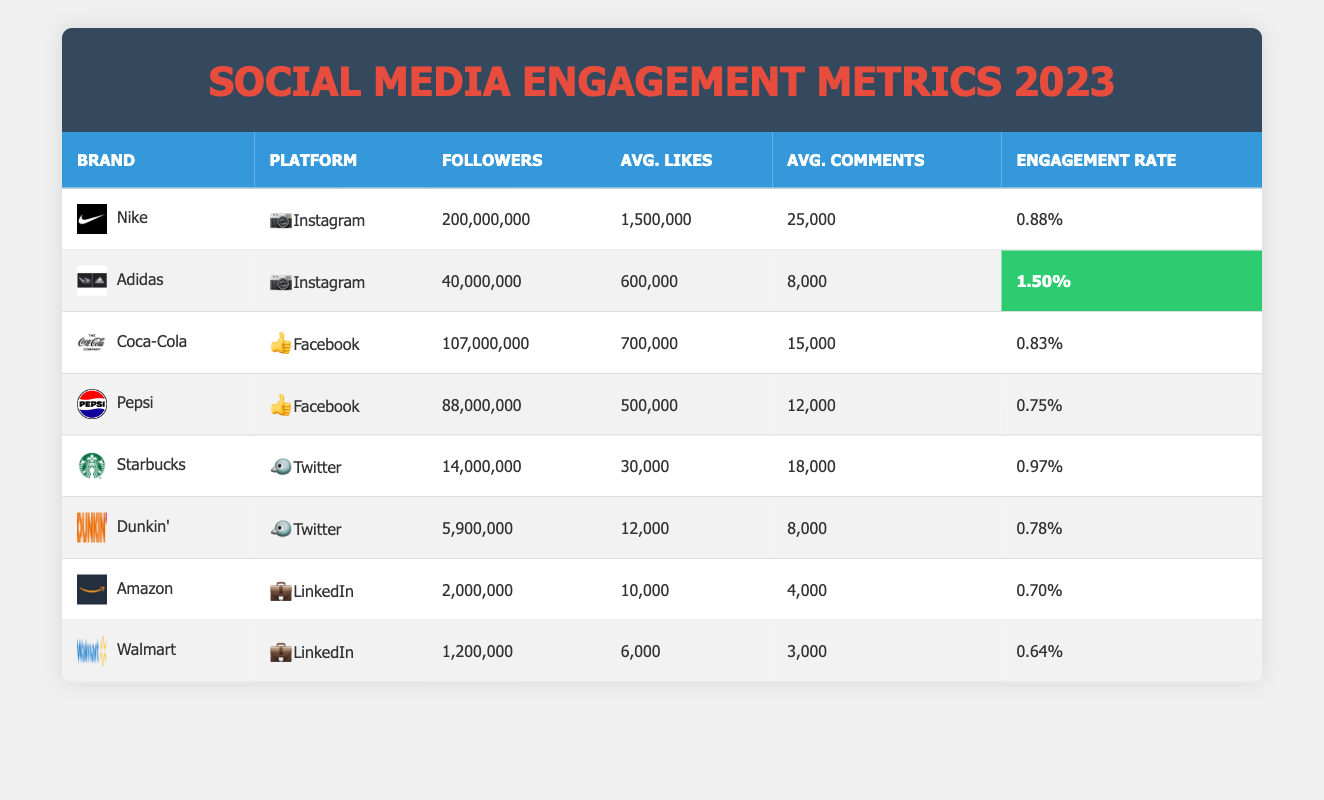What brand has the highest engagement rate on Instagram? Looking at the table, Adidas has the highest engagement rate on Instagram, listed as 1.5% next to the average likes and comments data.
Answer: Adidas Which brand has the most followers on Facebook? Coca-Cola has the most followers on Facebook with 107 million, compared to Pepsi's 88 million.
Answer: Coca-Cola How many average likes does Starbucks receive on Twitter? According to the table, Starbucks has an average of 30,000 likes on Twitter.
Answer: 30,000 What is the difference in followers between Nike and Adidas on Instagram? Nike has 200 million followers while Adidas has 40 million. The difference is 200 million - 40 million = 160 million.
Answer: 160 million Is Dunkin' more engaging than Walmart on LinkedIn? Dunkin' does not have a LinkedIn presence in this table, while Walmart has an engagement rate of 0.64%. It's impossible to compare as Dunkin' is not in the data for LinkedIn.
Answer: No What is the total average number of likes received by Coca-Cola and Pepsi on Facebook? Coca-Cola has 700,000 likes and Pepsi has 500,000 likes. The total is 700,000 + 500,000 = 1,200,000.
Answer: 1,200,000 Calculate the average engagement rate of all brands listed in the table. The engagement rates are 0.88, 1.5, 0.83, 0.75, 0.97, 0.78, 0.70, and 0.64. Summing these (0.88 + 1.5 + 0.83 + 0.75 + 0.97 + 0.78 + 0.70 + 0.64 = 6.15) and dividing by 8 gives an average engagement rate of 6.15/8 = 0.77125%.
Answer: 0.77% Which social media platform has the lowest average likes among the brands listed? On the table, LinkedIn shows the lowest average likes with Amazon at 10,000 and Walmart at 6,000. Walmart has the lowest at 6,000 likes.
Answer: Walmart Which brand has the fewest followers on Twitter? Dunkin' has the fewest followers on Twitter with 5.9 million, compared to Starbucks which has 14 million.
Answer: Dunkin' 